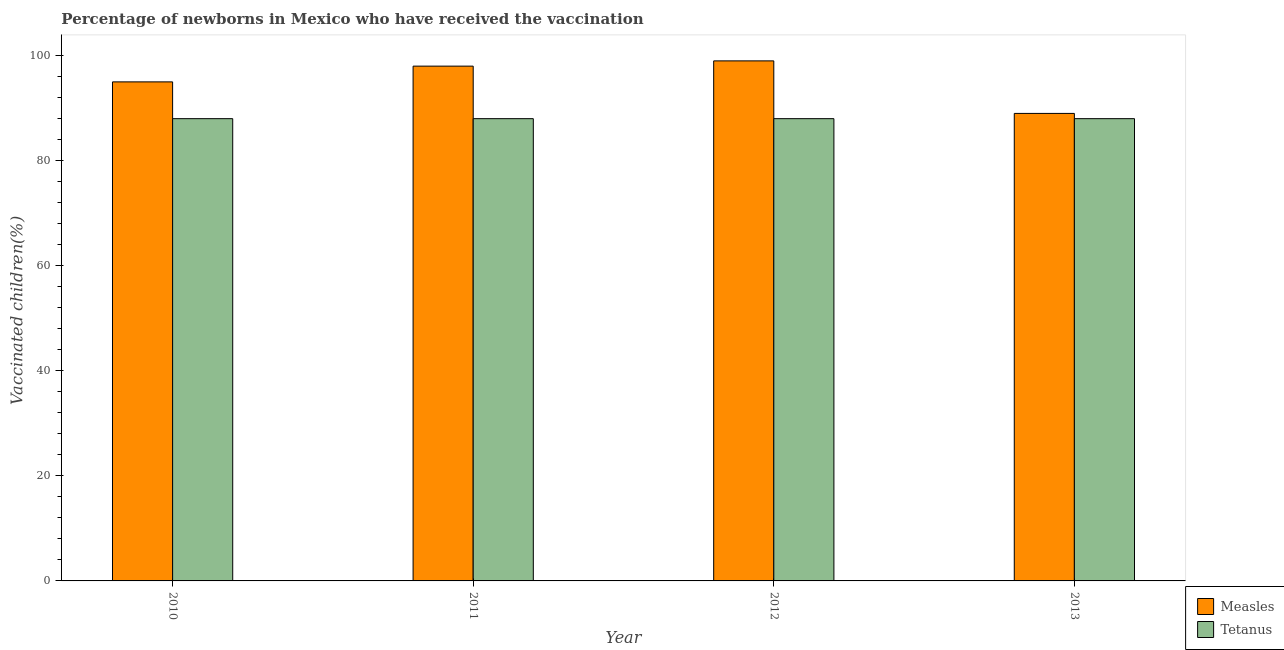How many different coloured bars are there?
Make the answer very short. 2. How many bars are there on the 3rd tick from the left?
Ensure brevity in your answer.  2. How many bars are there on the 4th tick from the right?
Keep it short and to the point. 2. What is the label of the 1st group of bars from the left?
Keep it short and to the point. 2010. In how many cases, is the number of bars for a given year not equal to the number of legend labels?
Make the answer very short. 0. What is the percentage of newborns who received vaccination for measles in 2012?
Ensure brevity in your answer.  99. Across all years, what is the maximum percentage of newborns who received vaccination for measles?
Make the answer very short. 99. Across all years, what is the minimum percentage of newborns who received vaccination for tetanus?
Offer a terse response. 88. In which year was the percentage of newborns who received vaccination for tetanus maximum?
Provide a short and direct response. 2010. In which year was the percentage of newborns who received vaccination for measles minimum?
Your answer should be very brief. 2013. What is the total percentage of newborns who received vaccination for measles in the graph?
Your response must be concise. 381. What is the difference between the percentage of newborns who received vaccination for measles in 2011 and that in 2013?
Ensure brevity in your answer.  9. What is the difference between the percentage of newborns who received vaccination for measles in 2011 and the percentage of newborns who received vaccination for tetanus in 2010?
Make the answer very short. 3. What is the ratio of the percentage of newborns who received vaccination for measles in 2011 to that in 2013?
Your answer should be compact. 1.1. What is the difference between the highest and the second highest percentage of newborns who received vaccination for tetanus?
Ensure brevity in your answer.  0. What is the difference between the highest and the lowest percentage of newborns who received vaccination for measles?
Offer a terse response. 10. What does the 2nd bar from the left in 2010 represents?
Give a very brief answer. Tetanus. What does the 1st bar from the right in 2013 represents?
Your answer should be compact. Tetanus. How many bars are there?
Keep it short and to the point. 8. Are all the bars in the graph horizontal?
Your answer should be compact. No. What is the title of the graph?
Make the answer very short. Percentage of newborns in Mexico who have received the vaccination. What is the label or title of the X-axis?
Give a very brief answer. Year. What is the label or title of the Y-axis?
Make the answer very short. Vaccinated children(%)
. What is the Vaccinated children(%)
 of Measles in 2010?
Your answer should be compact. 95. What is the Vaccinated children(%)
 in Tetanus in 2010?
Ensure brevity in your answer.  88. What is the Vaccinated children(%)
 of Tetanus in 2011?
Make the answer very short. 88. What is the Vaccinated children(%)
 of Tetanus in 2012?
Keep it short and to the point. 88. What is the Vaccinated children(%)
 of Measles in 2013?
Make the answer very short. 89. What is the Vaccinated children(%)
 of Tetanus in 2013?
Provide a short and direct response. 88. Across all years, what is the maximum Vaccinated children(%)
 in Tetanus?
Your answer should be compact. 88. Across all years, what is the minimum Vaccinated children(%)
 of Measles?
Give a very brief answer. 89. What is the total Vaccinated children(%)
 of Measles in the graph?
Your response must be concise. 381. What is the total Vaccinated children(%)
 of Tetanus in the graph?
Ensure brevity in your answer.  352. What is the difference between the Vaccinated children(%)
 of Measles in 2010 and that in 2011?
Offer a terse response. -3. What is the difference between the Vaccinated children(%)
 in Tetanus in 2010 and that in 2011?
Provide a short and direct response. 0. What is the difference between the Vaccinated children(%)
 in Tetanus in 2010 and that in 2012?
Your answer should be very brief. 0. What is the difference between the Vaccinated children(%)
 in Tetanus in 2011 and that in 2012?
Your response must be concise. 0. What is the difference between the Vaccinated children(%)
 in Measles in 2011 and that in 2013?
Offer a terse response. 9. What is the difference between the Vaccinated children(%)
 of Measles in 2012 and that in 2013?
Offer a very short reply. 10. What is the difference between the Vaccinated children(%)
 in Tetanus in 2012 and that in 2013?
Give a very brief answer. 0. What is the difference between the Vaccinated children(%)
 of Measles in 2010 and the Vaccinated children(%)
 of Tetanus in 2011?
Provide a succinct answer. 7. What is the difference between the Vaccinated children(%)
 in Measles in 2011 and the Vaccinated children(%)
 in Tetanus in 2013?
Your answer should be very brief. 10. What is the average Vaccinated children(%)
 in Measles per year?
Offer a very short reply. 95.25. What is the average Vaccinated children(%)
 of Tetanus per year?
Make the answer very short. 88. In the year 2010, what is the difference between the Vaccinated children(%)
 of Measles and Vaccinated children(%)
 of Tetanus?
Offer a very short reply. 7. In the year 2013, what is the difference between the Vaccinated children(%)
 in Measles and Vaccinated children(%)
 in Tetanus?
Provide a short and direct response. 1. What is the ratio of the Vaccinated children(%)
 in Measles in 2010 to that in 2011?
Provide a short and direct response. 0.97. What is the ratio of the Vaccinated children(%)
 of Tetanus in 2010 to that in 2011?
Provide a succinct answer. 1. What is the ratio of the Vaccinated children(%)
 in Measles in 2010 to that in 2012?
Offer a terse response. 0.96. What is the ratio of the Vaccinated children(%)
 in Tetanus in 2010 to that in 2012?
Ensure brevity in your answer.  1. What is the ratio of the Vaccinated children(%)
 in Measles in 2010 to that in 2013?
Your response must be concise. 1.07. What is the ratio of the Vaccinated children(%)
 in Tetanus in 2011 to that in 2012?
Offer a very short reply. 1. What is the ratio of the Vaccinated children(%)
 of Measles in 2011 to that in 2013?
Ensure brevity in your answer.  1.1. What is the ratio of the Vaccinated children(%)
 of Tetanus in 2011 to that in 2013?
Make the answer very short. 1. What is the ratio of the Vaccinated children(%)
 in Measles in 2012 to that in 2013?
Your response must be concise. 1.11. What is the ratio of the Vaccinated children(%)
 of Tetanus in 2012 to that in 2013?
Keep it short and to the point. 1. What is the difference between the highest and the second highest Vaccinated children(%)
 of Measles?
Keep it short and to the point. 1. What is the difference between the highest and the lowest Vaccinated children(%)
 of Measles?
Make the answer very short. 10. What is the difference between the highest and the lowest Vaccinated children(%)
 of Tetanus?
Provide a short and direct response. 0. 